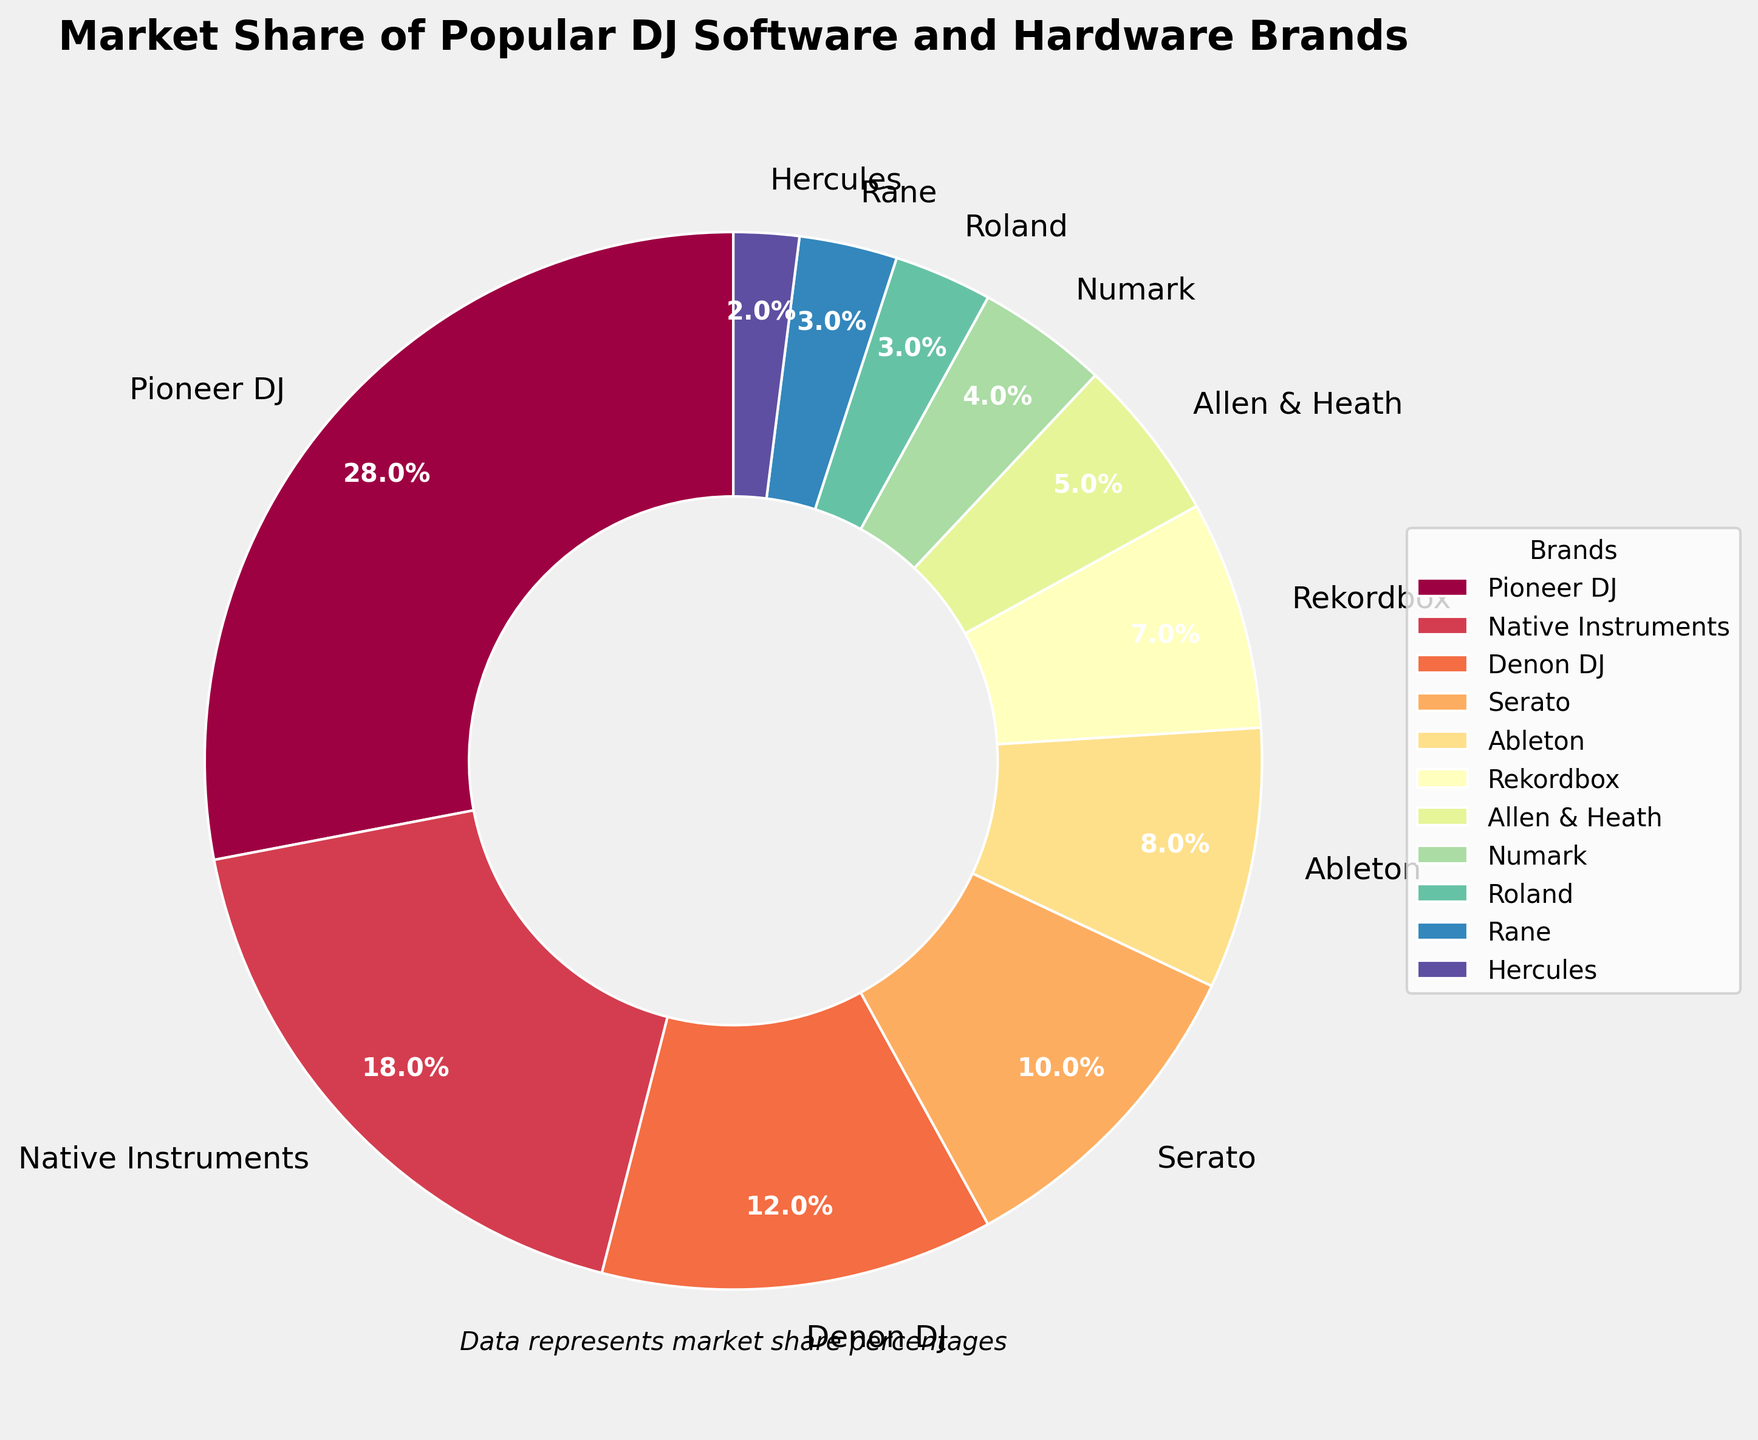What brand has the largest market share? The figure's largest wedge and the label indicate that Pioneer DJ holds the largest market share.
Answer: Pioneer DJ How much greater is Pioneer DJ's market share compared to Serato? Subtract Serato's market share (10%) from Pioneer DJ's market share (28%): 28% - 10% = 18%.
Answer: 18% Which brands together constitute the smallest 10% of the market? The smallest wedges belong to Hercules (2%), Roland (3%), and Rane (3%). Summing them: 2% + 3% + 3% = 8%, which is closest to 10%.
Answer: Hercules, Roland, Rane What is the combined market share of Denon DJ, Allen & Heath, and Numark? Summing the market shares: Denon DJ (12%) + Allen & Heath (5%) + Numark (4%) = 12% + 5% + 4% = 21%.
Answer: 21% Which brands have a market share of 10% or more? The wedges labeled with 10% or more are Pioneer DJ (28%), Native Instruments (18%), and Denon DJ (12%).
Answer: Pioneer DJ, Native Instruments, Denon DJ What is the difference in market share between Ableton and Rekordbox? Subtract Rekordbox’s market share (7%) from Ableton’s market share (8%): 8% - 7% = 1%.
Answer: 1% How many brands have a market share of 5% or less? The wedges showing 5% or less are Allen & Heath (5%), Numark (4%), Roland (3%), Rane (3%), and Hercules (2%).
Answer: 5 If you combine the market shares of Serato, Ableton, and Rekordbox, which brand does their total come closest to? Summing their market shares: Serato (10%) + Ableton (8%) + Rekordbox (7%) = 25%, closest to Pioneer DJ's 28%.
Answer: Pioneer DJ What is the total market share of brands that are not Pioneer DJ, Native Instruments, or Denon DJ? Subtract their total from 100%: 100% - (28% + 18% + 12%) = 100% - 58% = 42%.
Answer: 42% Which pie slice is colored the darkest? The color palette uses a spectral gradient; perhaps the first brand, Pioneer DJ, is the darkest.
Answer: Pioneer DJ 